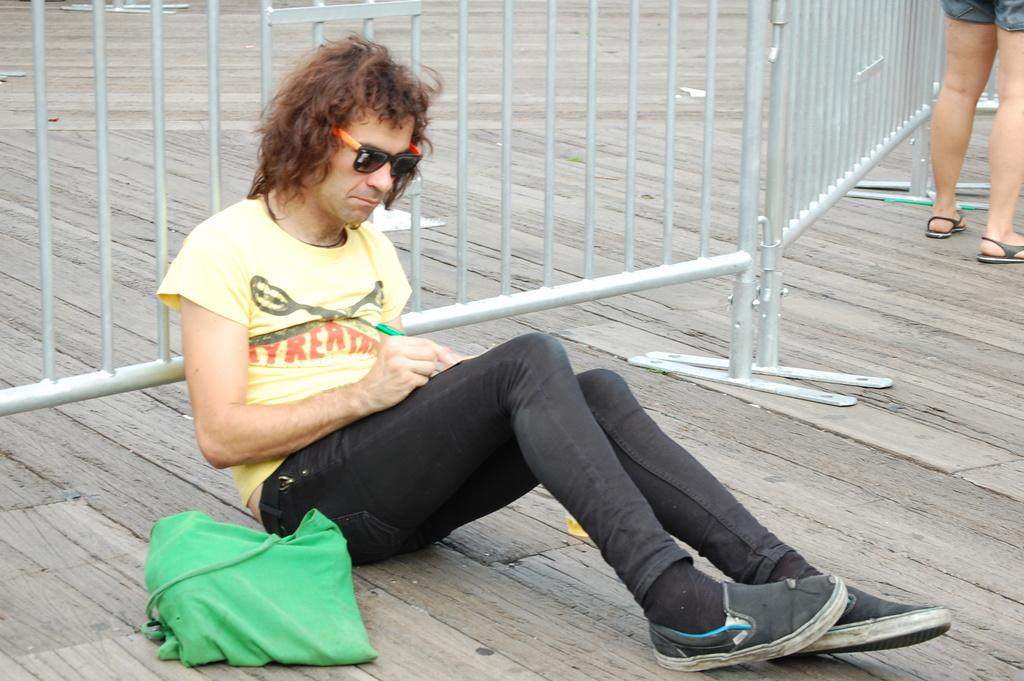What is the person in the foreground doing in the image? There is a person sitting on the road in the foreground. What is the person holding or carrying? The person has a bag. What can be seen in the background of the image? There is a fence in the background. Are there any other people visible in the image? Yes, there is another person standing in the background. When was the image taken? The image was taken during the day. What type of needle is the person using to sew the cloth in the image? There is no needle or cloth present in the image; the person is sitting on the road with a bag. What kind of pet can be seen accompanying the person in the image? There is no pet visible in the image; the person is sitting alone on the road. 